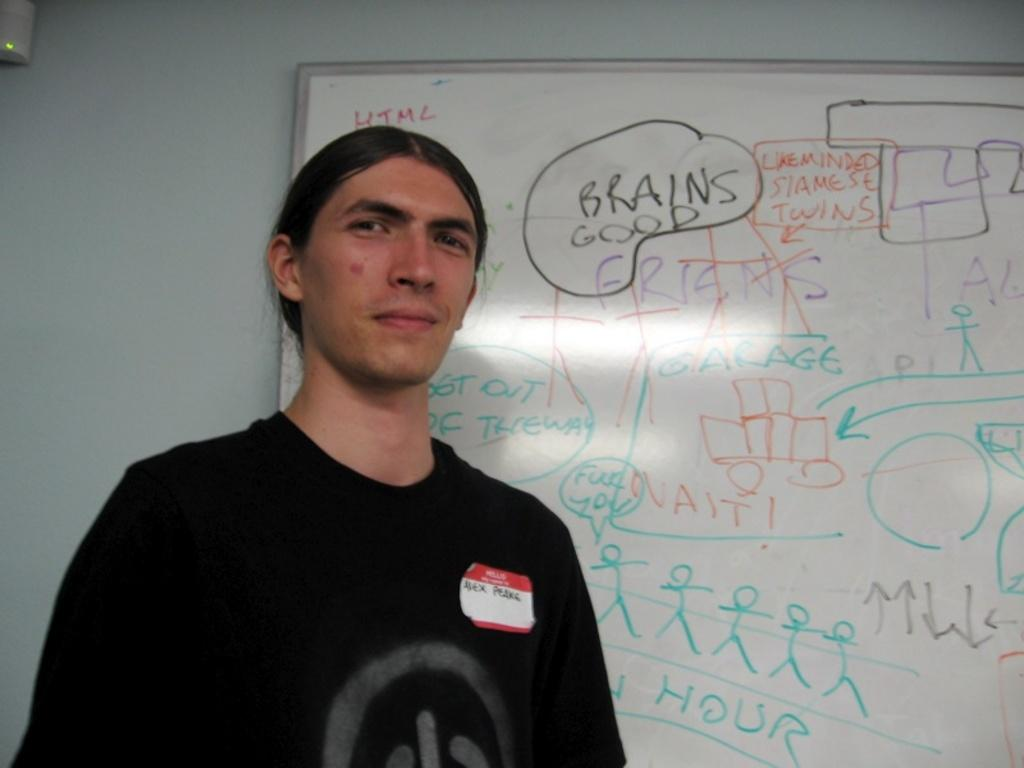<image>
Create a compact narrative representing the image presented. Man standing in front of a white board which says "Brain Goods". 